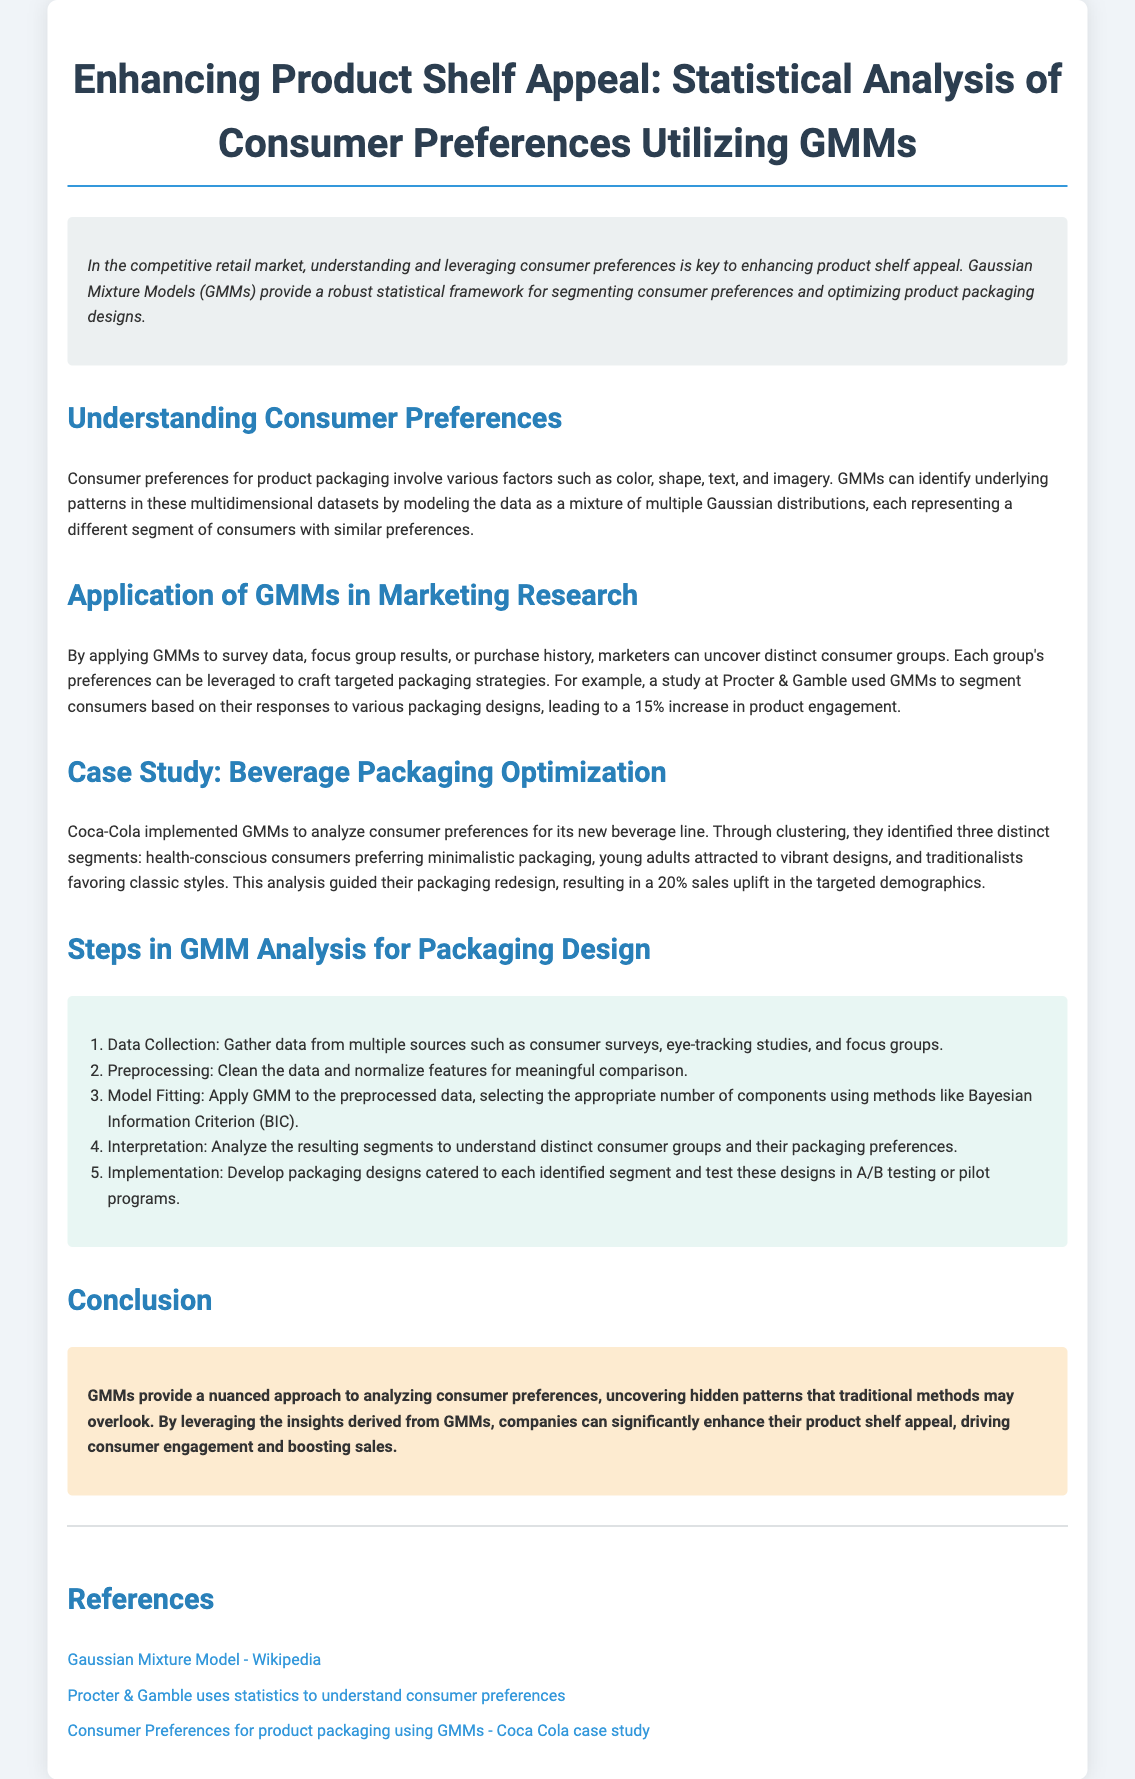What is the main statistical method discussed? The document discusses the application of Gaussian Mixture Models (GMMs) for analyzing consumer preferences.
Answer: Gaussian Mixture Models What percentage increase in product engagement was achieved by Procter & Gamble? Procter & Gamble achieved a 15% increase in product engagement after using GMMs.
Answer: 15% What are the three consumer segments identified by Coca-Cola? The three segments identified are health-conscious consumers, young adults, and traditionalists.
Answer: Health-conscious consumers, young adults, traditionalists What is the first step in GMM analysis for packaging design? The first step in GMM analysis is data collection, which involves gathering data from multiple sources.
Answer: Data Collection What is the background color of the container in the document? The background color of the container mentioned in the document is white.
Answer: White What does the GMM analysis help marketers to uncover? GMM analysis helps marketers to uncover distinct consumer groups based on their preferences for packaging.
Answer: Distinct consumer groups What was the sales uplift achieved by Coca-Cola's packaging redesign? Coca-Cola achieved a 20% sales uplift following their packaging redesign guided by GMM analysis.
Answer: 20% In which section is the case study of Coca-Cola included? The case study of Coca-Cola is included in the "Case Study: Beverage Packaging Optimization" section.
Answer: Case Study: Beverage Packaging Optimization 